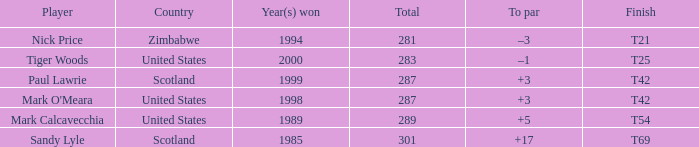What is tiger woods' score in relation to par? –1. 